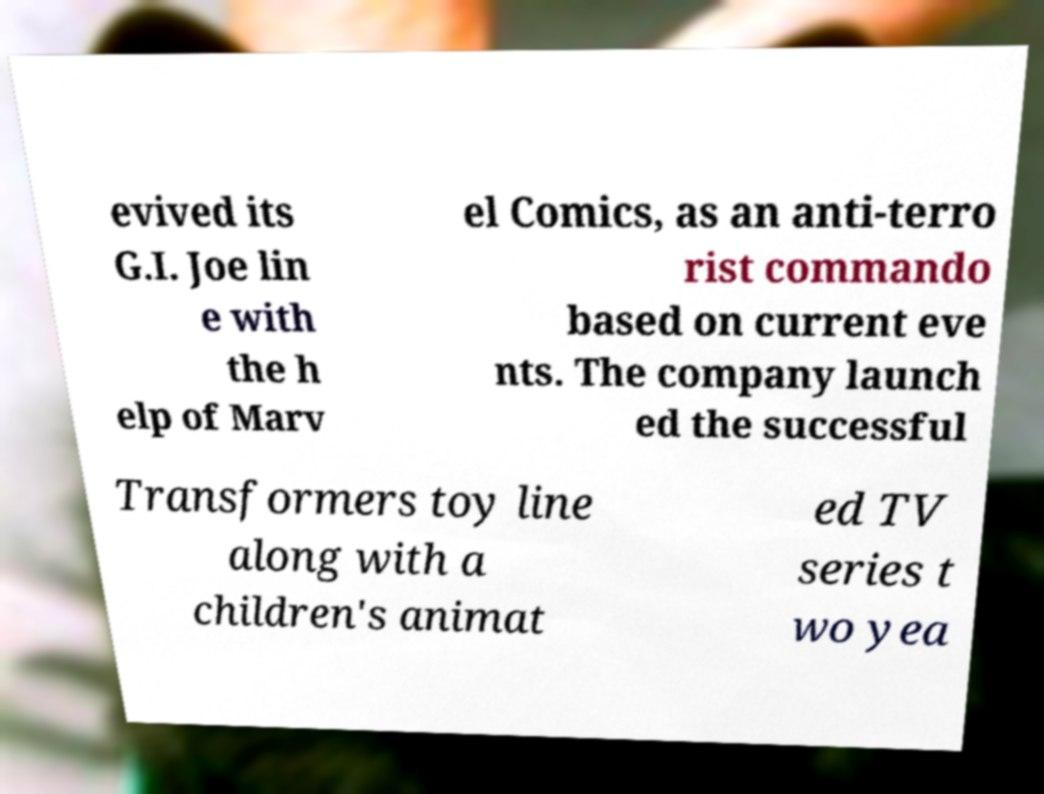Please identify and transcribe the text found in this image. evived its G.I. Joe lin e with the h elp of Marv el Comics, as an anti-terro rist commando based on current eve nts. The company launch ed the successful Transformers toy line along with a children's animat ed TV series t wo yea 